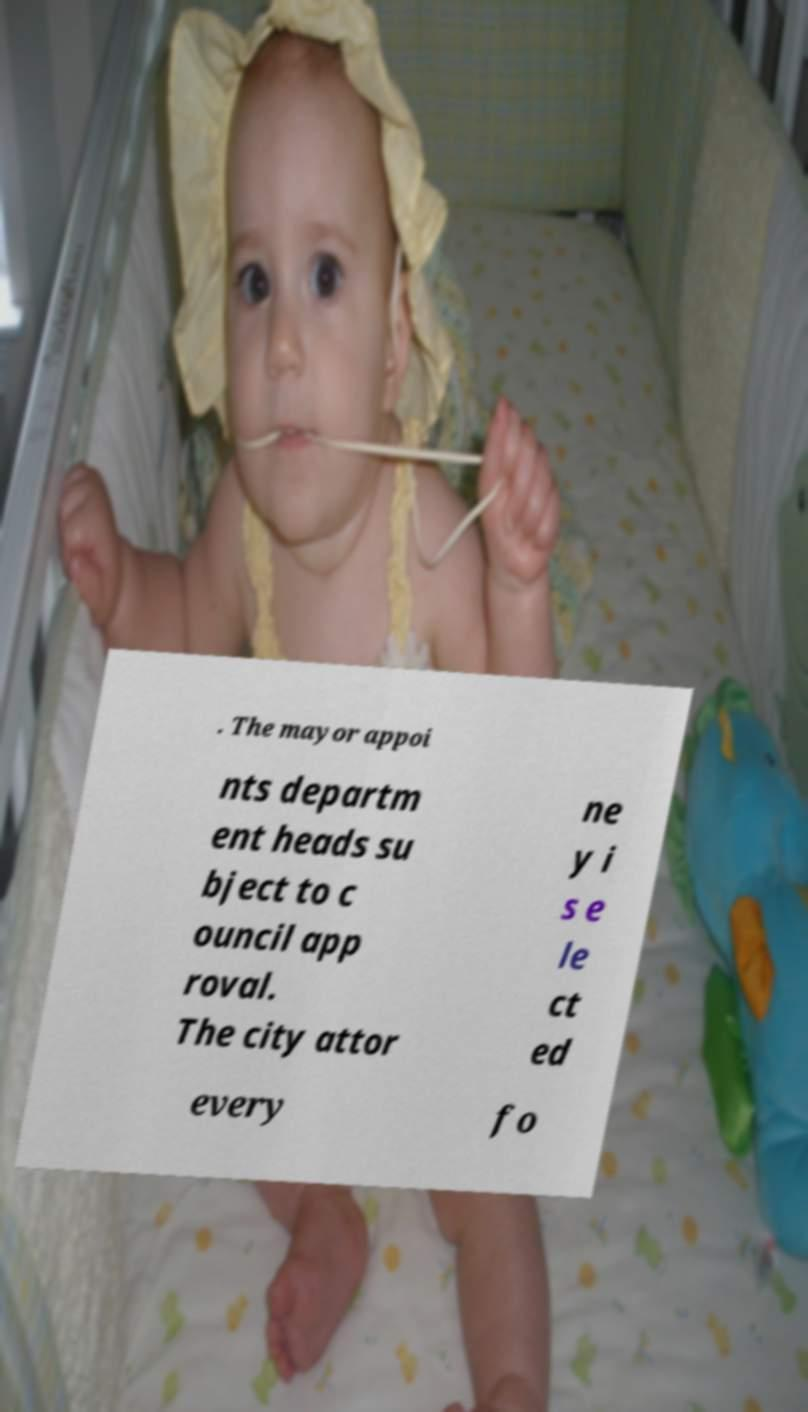Please read and relay the text visible in this image. What does it say? . The mayor appoi nts departm ent heads su bject to c ouncil app roval. The city attor ne y i s e le ct ed every fo 